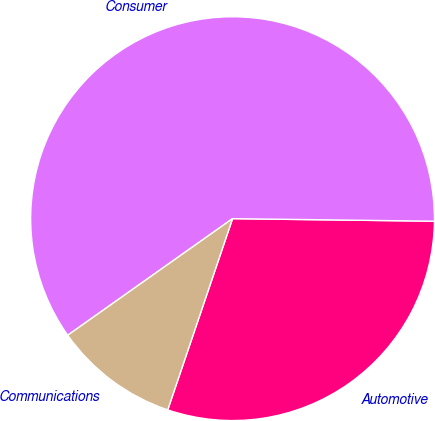Convert chart to OTSL. <chart><loc_0><loc_0><loc_500><loc_500><pie_chart><fcel>Automotive<fcel>Consumer<fcel>Communications<nl><fcel>30.0%<fcel>60.0%<fcel>10.0%<nl></chart> 